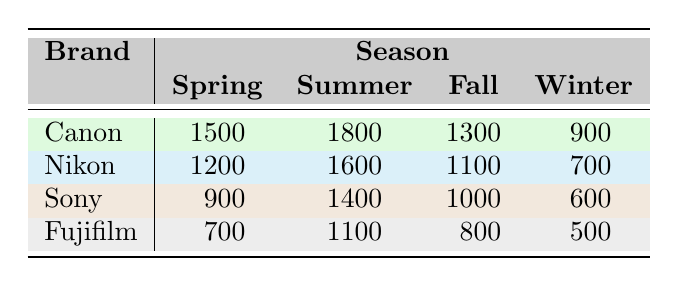What is the total number of units sold for Canon in Summer? From the table, the units sold for Canon in Summer is 1800. Thus, the total units sold specifically during that season for Canon's brand is simply 1800.
Answer: 1800 Which brand had the lowest sales in Winter? Referring to the Winter column, Fujifilm has the lowest sales at 500 units sold. The other brands (Canon, Nikon, and Sony) have higher sales numbers (900, 700, and 600 respectively).
Answer: Fujifilm What is the difference in units sold between Nikon's Spring and Fall sales? The units sold for Nikon in Spring is 1200, and in Fall is 1100. The difference is calculated as 1200 - 1100 = 100.
Answer: 100 What is the average number of units sold across all brands in Spring? To calculate the average for Spring, we sum the units sold for all brands: Canon (1500) + Nikon (1200) + Sony (900) + Fujifilm (700) = 4300. Since there are 4 brands, we divide this by 4: 4300 / 4 = 1075.
Answer: 1075 Did Sony sell more units in Summer than in Fall? Looking at the table, Sony sold 1400 units in Summer and 1000 units in Fall. Since 1400 is greater than 1000, the answer is yes.
Answer: Yes Which brand consistently had the highest sales across all seasons? By examining the table, Canon has the highest units sold in Spring (1500), Summer (1800), and Fall (1300). It is also the second highest in Winter (900). Therefore, Canon consistently shows higher numbers overall compared to other brands.
Answer: Canon What is the total number of units sold for all brands in Fall? The total for Fall can be calculated by summing the units sold: Canon (1300) + Nikon (1100) + Sony (1000) + Fujifilm (800) = 4200. Hence, the total units sold in Fall across all brands is 4200.
Answer: 4200 Who had higher sales in Summer: Nikon or Sony? In the table, Nikon sold 1600 units and Sony sold 1400 units in Summer. Since 1600 is greater than 1400, Nikon had higher sales.
Answer: Nikon 